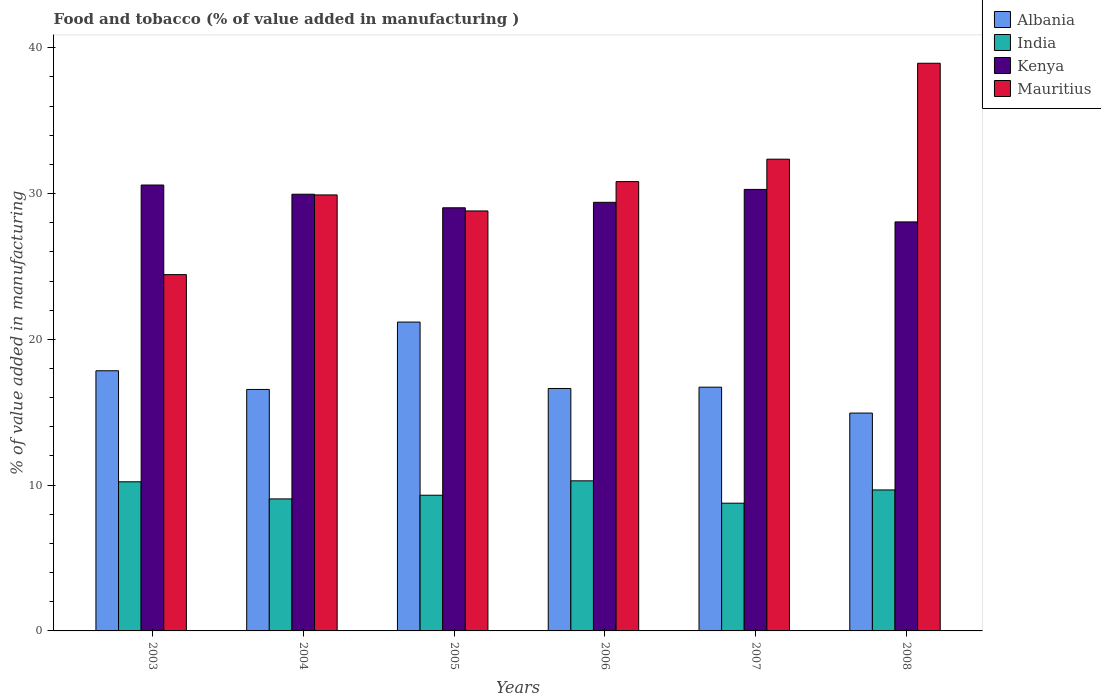How many groups of bars are there?
Your answer should be compact. 6. What is the label of the 3rd group of bars from the left?
Your answer should be very brief. 2005. What is the value added in manufacturing food and tobacco in India in 2007?
Offer a terse response. 8.76. Across all years, what is the maximum value added in manufacturing food and tobacco in Kenya?
Provide a succinct answer. 30.59. Across all years, what is the minimum value added in manufacturing food and tobacco in India?
Ensure brevity in your answer.  8.76. In which year was the value added in manufacturing food and tobacco in Albania minimum?
Keep it short and to the point. 2008. What is the total value added in manufacturing food and tobacco in Mauritius in the graph?
Make the answer very short. 185.29. What is the difference between the value added in manufacturing food and tobacco in India in 2004 and that in 2006?
Give a very brief answer. -1.24. What is the difference between the value added in manufacturing food and tobacco in India in 2008 and the value added in manufacturing food and tobacco in Albania in 2005?
Provide a succinct answer. -11.52. What is the average value added in manufacturing food and tobacco in Mauritius per year?
Make the answer very short. 30.88. In the year 2003, what is the difference between the value added in manufacturing food and tobacco in Mauritius and value added in manufacturing food and tobacco in Kenya?
Your answer should be very brief. -6.15. In how many years, is the value added in manufacturing food and tobacco in Albania greater than 12 %?
Make the answer very short. 6. What is the ratio of the value added in manufacturing food and tobacco in India in 2004 to that in 2008?
Give a very brief answer. 0.94. Is the difference between the value added in manufacturing food and tobacco in Mauritius in 2006 and 2008 greater than the difference between the value added in manufacturing food and tobacco in Kenya in 2006 and 2008?
Make the answer very short. No. What is the difference between the highest and the second highest value added in manufacturing food and tobacco in Kenya?
Your response must be concise. 0.3. What is the difference between the highest and the lowest value added in manufacturing food and tobacco in Albania?
Your answer should be compact. 6.24. In how many years, is the value added in manufacturing food and tobacco in Mauritius greater than the average value added in manufacturing food and tobacco in Mauritius taken over all years?
Your response must be concise. 2. Is the sum of the value added in manufacturing food and tobacco in India in 2003 and 2008 greater than the maximum value added in manufacturing food and tobacco in Mauritius across all years?
Provide a succinct answer. No. Is it the case that in every year, the sum of the value added in manufacturing food and tobacco in India and value added in manufacturing food and tobacco in Albania is greater than the sum of value added in manufacturing food and tobacco in Mauritius and value added in manufacturing food and tobacco in Kenya?
Give a very brief answer. No. What does the 4th bar from the left in 2003 represents?
Offer a terse response. Mauritius. What does the 2nd bar from the right in 2006 represents?
Your response must be concise. Kenya. What is the difference between two consecutive major ticks on the Y-axis?
Offer a terse response. 10. Does the graph contain grids?
Ensure brevity in your answer.  No. Where does the legend appear in the graph?
Ensure brevity in your answer.  Top right. How many legend labels are there?
Your answer should be very brief. 4. What is the title of the graph?
Your answer should be compact. Food and tobacco (% of value added in manufacturing ). Does "Burkina Faso" appear as one of the legend labels in the graph?
Make the answer very short. No. What is the label or title of the X-axis?
Your answer should be very brief. Years. What is the label or title of the Y-axis?
Give a very brief answer. % of value added in manufacturing. What is the % of value added in manufacturing in Albania in 2003?
Keep it short and to the point. 17.85. What is the % of value added in manufacturing in India in 2003?
Provide a succinct answer. 10.23. What is the % of value added in manufacturing in Kenya in 2003?
Ensure brevity in your answer.  30.59. What is the % of value added in manufacturing in Mauritius in 2003?
Keep it short and to the point. 24.44. What is the % of value added in manufacturing in Albania in 2004?
Provide a short and direct response. 16.57. What is the % of value added in manufacturing of India in 2004?
Provide a short and direct response. 9.06. What is the % of value added in manufacturing of Kenya in 2004?
Your answer should be compact. 29.96. What is the % of value added in manufacturing in Mauritius in 2004?
Your answer should be very brief. 29.91. What is the % of value added in manufacturing in Albania in 2005?
Offer a terse response. 21.19. What is the % of value added in manufacturing in India in 2005?
Provide a succinct answer. 9.31. What is the % of value added in manufacturing of Kenya in 2005?
Your answer should be very brief. 29.03. What is the % of value added in manufacturing of Mauritius in 2005?
Ensure brevity in your answer.  28.81. What is the % of value added in manufacturing of Albania in 2006?
Your answer should be compact. 16.63. What is the % of value added in manufacturing of India in 2006?
Keep it short and to the point. 10.3. What is the % of value added in manufacturing in Kenya in 2006?
Make the answer very short. 29.4. What is the % of value added in manufacturing in Mauritius in 2006?
Your response must be concise. 30.82. What is the % of value added in manufacturing of Albania in 2007?
Give a very brief answer. 16.72. What is the % of value added in manufacturing of India in 2007?
Give a very brief answer. 8.76. What is the % of value added in manufacturing in Kenya in 2007?
Your answer should be compact. 30.29. What is the % of value added in manufacturing in Mauritius in 2007?
Keep it short and to the point. 32.36. What is the % of value added in manufacturing in Albania in 2008?
Offer a very short reply. 14.95. What is the % of value added in manufacturing of India in 2008?
Offer a very short reply. 9.67. What is the % of value added in manufacturing of Kenya in 2008?
Your response must be concise. 28.06. What is the % of value added in manufacturing in Mauritius in 2008?
Offer a very short reply. 38.94. Across all years, what is the maximum % of value added in manufacturing in Albania?
Give a very brief answer. 21.19. Across all years, what is the maximum % of value added in manufacturing of India?
Give a very brief answer. 10.3. Across all years, what is the maximum % of value added in manufacturing in Kenya?
Provide a succinct answer. 30.59. Across all years, what is the maximum % of value added in manufacturing of Mauritius?
Your answer should be compact. 38.94. Across all years, what is the minimum % of value added in manufacturing of Albania?
Make the answer very short. 14.95. Across all years, what is the minimum % of value added in manufacturing of India?
Provide a succinct answer. 8.76. Across all years, what is the minimum % of value added in manufacturing in Kenya?
Offer a very short reply. 28.06. Across all years, what is the minimum % of value added in manufacturing in Mauritius?
Provide a succinct answer. 24.44. What is the total % of value added in manufacturing in Albania in the graph?
Ensure brevity in your answer.  103.9. What is the total % of value added in manufacturing in India in the graph?
Your answer should be compact. 57.33. What is the total % of value added in manufacturing of Kenya in the graph?
Your answer should be very brief. 177.33. What is the total % of value added in manufacturing of Mauritius in the graph?
Offer a terse response. 185.29. What is the difference between the % of value added in manufacturing of Albania in 2003 and that in 2004?
Offer a very short reply. 1.28. What is the difference between the % of value added in manufacturing of India in 2003 and that in 2004?
Your answer should be compact. 1.17. What is the difference between the % of value added in manufacturing of Kenya in 2003 and that in 2004?
Your answer should be very brief. 0.63. What is the difference between the % of value added in manufacturing in Mauritius in 2003 and that in 2004?
Your answer should be very brief. -5.47. What is the difference between the % of value added in manufacturing in Albania in 2003 and that in 2005?
Provide a short and direct response. -3.34. What is the difference between the % of value added in manufacturing in India in 2003 and that in 2005?
Give a very brief answer. 0.92. What is the difference between the % of value added in manufacturing in Kenya in 2003 and that in 2005?
Offer a terse response. 1.56. What is the difference between the % of value added in manufacturing of Mauritius in 2003 and that in 2005?
Make the answer very short. -4.37. What is the difference between the % of value added in manufacturing in Albania in 2003 and that in 2006?
Make the answer very short. 1.22. What is the difference between the % of value added in manufacturing in India in 2003 and that in 2006?
Your answer should be very brief. -0.07. What is the difference between the % of value added in manufacturing of Kenya in 2003 and that in 2006?
Provide a succinct answer. 1.19. What is the difference between the % of value added in manufacturing of Mauritius in 2003 and that in 2006?
Your answer should be compact. -6.38. What is the difference between the % of value added in manufacturing in Albania in 2003 and that in 2007?
Provide a short and direct response. 1.13. What is the difference between the % of value added in manufacturing in India in 2003 and that in 2007?
Your response must be concise. 1.47. What is the difference between the % of value added in manufacturing in Kenya in 2003 and that in 2007?
Provide a succinct answer. 0.3. What is the difference between the % of value added in manufacturing in Mauritius in 2003 and that in 2007?
Offer a very short reply. -7.92. What is the difference between the % of value added in manufacturing of Albania in 2003 and that in 2008?
Make the answer very short. 2.9. What is the difference between the % of value added in manufacturing of India in 2003 and that in 2008?
Keep it short and to the point. 0.56. What is the difference between the % of value added in manufacturing in Kenya in 2003 and that in 2008?
Offer a terse response. 2.53. What is the difference between the % of value added in manufacturing of Mauritius in 2003 and that in 2008?
Keep it short and to the point. -14.5. What is the difference between the % of value added in manufacturing of Albania in 2004 and that in 2005?
Your answer should be compact. -4.62. What is the difference between the % of value added in manufacturing of India in 2004 and that in 2005?
Provide a succinct answer. -0.25. What is the difference between the % of value added in manufacturing of Kenya in 2004 and that in 2005?
Offer a very short reply. 0.93. What is the difference between the % of value added in manufacturing of Mauritius in 2004 and that in 2005?
Your response must be concise. 1.1. What is the difference between the % of value added in manufacturing of Albania in 2004 and that in 2006?
Make the answer very short. -0.07. What is the difference between the % of value added in manufacturing in India in 2004 and that in 2006?
Offer a terse response. -1.24. What is the difference between the % of value added in manufacturing in Kenya in 2004 and that in 2006?
Offer a terse response. 0.56. What is the difference between the % of value added in manufacturing of Mauritius in 2004 and that in 2006?
Make the answer very short. -0.91. What is the difference between the % of value added in manufacturing in Albania in 2004 and that in 2007?
Ensure brevity in your answer.  -0.16. What is the difference between the % of value added in manufacturing in India in 2004 and that in 2007?
Your response must be concise. 0.29. What is the difference between the % of value added in manufacturing in Kenya in 2004 and that in 2007?
Provide a succinct answer. -0.33. What is the difference between the % of value added in manufacturing in Mauritius in 2004 and that in 2007?
Offer a terse response. -2.45. What is the difference between the % of value added in manufacturing of Albania in 2004 and that in 2008?
Ensure brevity in your answer.  1.62. What is the difference between the % of value added in manufacturing of India in 2004 and that in 2008?
Your response must be concise. -0.61. What is the difference between the % of value added in manufacturing of Kenya in 2004 and that in 2008?
Your response must be concise. 1.9. What is the difference between the % of value added in manufacturing of Mauritius in 2004 and that in 2008?
Ensure brevity in your answer.  -9.03. What is the difference between the % of value added in manufacturing in Albania in 2005 and that in 2006?
Your answer should be compact. 4.56. What is the difference between the % of value added in manufacturing in India in 2005 and that in 2006?
Your answer should be very brief. -0.99. What is the difference between the % of value added in manufacturing of Kenya in 2005 and that in 2006?
Ensure brevity in your answer.  -0.38. What is the difference between the % of value added in manufacturing of Mauritius in 2005 and that in 2006?
Your answer should be compact. -2.01. What is the difference between the % of value added in manufacturing in Albania in 2005 and that in 2007?
Offer a terse response. 4.47. What is the difference between the % of value added in manufacturing in India in 2005 and that in 2007?
Make the answer very short. 0.55. What is the difference between the % of value added in manufacturing of Kenya in 2005 and that in 2007?
Your response must be concise. -1.26. What is the difference between the % of value added in manufacturing in Mauritius in 2005 and that in 2007?
Provide a short and direct response. -3.55. What is the difference between the % of value added in manufacturing of Albania in 2005 and that in 2008?
Your answer should be very brief. 6.24. What is the difference between the % of value added in manufacturing in India in 2005 and that in 2008?
Make the answer very short. -0.36. What is the difference between the % of value added in manufacturing in Kenya in 2005 and that in 2008?
Provide a short and direct response. 0.97. What is the difference between the % of value added in manufacturing of Mauritius in 2005 and that in 2008?
Provide a succinct answer. -10.13. What is the difference between the % of value added in manufacturing of Albania in 2006 and that in 2007?
Offer a terse response. -0.09. What is the difference between the % of value added in manufacturing in India in 2006 and that in 2007?
Provide a short and direct response. 1.53. What is the difference between the % of value added in manufacturing of Kenya in 2006 and that in 2007?
Your answer should be compact. -0.89. What is the difference between the % of value added in manufacturing in Mauritius in 2006 and that in 2007?
Your answer should be very brief. -1.54. What is the difference between the % of value added in manufacturing in Albania in 2006 and that in 2008?
Provide a succinct answer. 1.69. What is the difference between the % of value added in manufacturing in India in 2006 and that in 2008?
Your response must be concise. 0.63. What is the difference between the % of value added in manufacturing in Kenya in 2006 and that in 2008?
Offer a very short reply. 1.34. What is the difference between the % of value added in manufacturing of Mauritius in 2006 and that in 2008?
Offer a terse response. -8.12. What is the difference between the % of value added in manufacturing in Albania in 2007 and that in 2008?
Your answer should be very brief. 1.78. What is the difference between the % of value added in manufacturing of India in 2007 and that in 2008?
Provide a short and direct response. -0.91. What is the difference between the % of value added in manufacturing of Kenya in 2007 and that in 2008?
Your response must be concise. 2.23. What is the difference between the % of value added in manufacturing in Mauritius in 2007 and that in 2008?
Offer a terse response. -6.58. What is the difference between the % of value added in manufacturing in Albania in 2003 and the % of value added in manufacturing in India in 2004?
Your answer should be very brief. 8.79. What is the difference between the % of value added in manufacturing of Albania in 2003 and the % of value added in manufacturing of Kenya in 2004?
Provide a short and direct response. -12.11. What is the difference between the % of value added in manufacturing of Albania in 2003 and the % of value added in manufacturing of Mauritius in 2004?
Ensure brevity in your answer.  -12.06. What is the difference between the % of value added in manufacturing in India in 2003 and the % of value added in manufacturing in Kenya in 2004?
Keep it short and to the point. -19.73. What is the difference between the % of value added in manufacturing of India in 2003 and the % of value added in manufacturing of Mauritius in 2004?
Ensure brevity in your answer.  -19.68. What is the difference between the % of value added in manufacturing of Kenya in 2003 and the % of value added in manufacturing of Mauritius in 2004?
Offer a terse response. 0.68. What is the difference between the % of value added in manufacturing in Albania in 2003 and the % of value added in manufacturing in India in 2005?
Your answer should be compact. 8.54. What is the difference between the % of value added in manufacturing of Albania in 2003 and the % of value added in manufacturing of Kenya in 2005?
Your answer should be very brief. -11.18. What is the difference between the % of value added in manufacturing of Albania in 2003 and the % of value added in manufacturing of Mauritius in 2005?
Provide a succinct answer. -10.96. What is the difference between the % of value added in manufacturing of India in 2003 and the % of value added in manufacturing of Kenya in 2005?
Your response must be concise. -18.8. What is the difference between the % of value added in manufacturing of India in 2003 and the % of value added in manufacturing of Mauritius in 2005?
Provide a succinct answer. -18.58. What is the difference between the % of value added in manufacturing in Kenya in 2003 and the % of value added in manufacturing in Mauritius in 2005?
Make the answer very short. 1.78. What is the difference between the % of value added in manufacturing of Albania in 2003 and the % of value added in manufacturing of India in 2006?
Your answer should be compact. 7.55. What is the difference between the % of value added in manufacturing in Albania in 2003 and the % of value added in manufacturing in Kenya in 2006?
Your answer should be very brief. -11.56. What is the difference between the % of value added in manufacturing of Albania in 2003 and the % of value added in manufacturing of Mauritius in 2006?
Provide a short and direct response. -12.98. What is the difference between the % of value added in manufacturing of India in 2003 and the % of value added in manufacturing of Kenya in 2006?
Provide a short and direct response. -19.17. What is the difference between the % of value added in manufacturing of India in 2003 and the % of value added in manufacturing of Mauritius in 2006?
Offer a very short reply. -20.59. What is the difference between the % of value added in manufacturing in Kenya in 2003 and the % of value added in manufacturing in Mauritius in 2006?
Offer a terse response. -0.23. What is the difference between the % of value added in manufacturing in Albania in 2003 and the % of value added in manufacturing in India in 2007?
Provide a succinct answer. 9.08. What is the difference between the % of value added in manufacturing in Albania in 2003 and the % of value added in manufacturing in Kenya in 2007?
Offer a terse response. -12.44. What is the difference between the % of value added in manufacturing of Albania in 2003 and the % of value added in manufacturing of Mauritius in 2007?
Your answer should be compact. -14.52. What is the difference between the % of value added in manufacturing in India in 2003 and the % of value added in manufacturing in Kenya in 2007?
Provide a short and direct response. -20.06. What is the difference between the % of value added in manufacturing of India in 2003 and the % of value added in manufacturing of Mauritius in 2007?
Provide a short and direct response. -22.13. What is the difference between the % of value added in manufacturing of Kenya in 2003 and the % of value added in manufacturing of Mauritius in 2007?
Give a very brief answer. -1.77. What is the difference between the % of value added in manufacturing in Albania in 2003 and the % of value added in manufacturing in India in 2008?
Your answer should be compact. 8.18. What is the difference between the % of value added in manufacturing of Albania in 2003 and the % of value added in manufacturing of Kenya in 2008?
Your answer should be very brief. -10.21. What is the difference between the % of value added in manufacturing of Albania in 2003 and the % of value added in manufacturing of Mauritius in 2008?
Your answer should be compact. -21.1. What is the difference between the % of value added in manufacturing in India in 2003 and the % of value added in manufacturing in Kenya in 2008?
Offer a terse response. -17.83. What is the difference between the % of value added in manufacturing of India in 2003 and the % of value added in manufacturing of Mauritius in 2008?
Ensure brevity in your answer.  -28.71. What is the difference between the % of value added in manufacturing of Kenya in 2003 and the % of value added in manufacturing of Mauritius in 2008?
Provide a succinct answer. -8.35. What is the difference between the % of value added in manufacturing of Albania in 2004 and the % of value added in manufacturing of India in 2005?
Give a very brief answer. 7.26. What is the difference between the % of value added in manufacturing of Albania in 2004 and the % of value added in manufacturing of Kenya in 2005?
Give a very brief answer. -12.46. What is the difference between the % of value added in manufacturing of Albania in 2004 and the % of value added in manufacturing of Mauritius in 2005?
Provide a succinct answer. -12.25. What is the difference between the % of value added in manufacturing of India in 2004 and the % of value added in manufacturing of Kenya in 2005?
Your answer should be compact. -19.97. What is the difference between the % of value added in manufacturing of India in 2004 and the % of value added in manufacturing of Mauritius in 2005?
Your answer should be compact. -19.75. What is the difference between the % of value added in manufacturing in Kenya in 2004 and the % of value added in manufacturing in Mauritius in 2005?
Your response must be concise. 1.15. What is the difference between the % of value added in manufacturing in Albania in 2004 and the % of value added in manufacturing in India in 2006?
Provide a succinct answer. 6.27. What is the difference between the % of value added in manufacturing in Albania in 2004 and the % of value added in manufacturing in Kenya in 2006?
Offer a terse response. -12.84. What is the difference between the % of value added in manufacturing of Albania in 2004 and the % of value added in manufacturing of Mauritius in 2006?
Your answer should be very brief. -14.26. What is the difference between the % of value added in manufacturing of India in 2004 and the % of value added in manufacturing of Kenya in 2006?
Make the answer very short. -20.35. What is the difference between the % of value added in manufacturing of India in 2004 and the % of value added in manufacturing of Mauritius in 2006?
Ensure brevity in your answer.  -21.77. What is the difference between the % of value added in manufacturing in Kenya in 2004 and the % of value added in manufacturing in Mauritius in 2006?
Keep it short and to the point. -0.87. What is the difference between the % of value added in manufacturing in Albania in 2004 and the % of value added in manufacturing in India in 2007?
Offer a terse response. 7.8. What is the difference between the % of value added in manufacturing of Albania in 2004 and the % of value added in manufacturing of Kenya in 2007?
Give a very brief answer. -13.72. What is the difference between the % of value added in manufacturing in Albania in 2004 and the % of value added in manufacturing in Mauritius in 2007?
Your response must be concise. -15.8. What is the difference between the % of value added in manufacturing of India in 2004 and the % of value added in manufacturing of Kenya in 2007?
Your answer should be very brief. -21.23. What is the difference between the % of value added in manufacturing of India in 2004 and the % of value added in manufacturing of Mauritius in 2007?
Offer a very short reply. -23.31. What is the difference between the % of value added in manufacturing of Kenya in 2004 and the % of value added in manufacturing of Mauritius in 2007?
Provide a succinct answer. -2.4. What is the difference between the % of value added in manufacturing in Albania in 2004 and the % of value added in manufacturing in India in 2008?
Offer a terse response. 6.89. What is the difference between the % of value added in manufacturing in Albania in 2004 and the % of value added in manufacturing in Kenya in 2008?
Offer a terse response. -11.49. What is the difference between the % of value added in manufacturing of Albania in 2004 and the % of value added in manufacturing of Mauritius in 2008?
Offer a terse response. -22.38. What is the difference between the % of value added in manufacturing in India in 2004 and the % of value added in manufacturing in Kenya in 2008?
Offer a very short reply. -19. What is the difference between the % of value added in manufacturing of India in 2004 and the % of value added in manufacturing of Mauritius in 2008?
Provide a short and direct response. -29.89. What is the difference between the % of value added in manufacturing of Kenya in 2004 and the % of value added in manufacturing of Mauritius in 2008?
Offer a terse response. -8.98. What is the difference between the % of value added in manufacturing of Albania in 2005 and the % of value added in manufacturing of India in 2006?
Keep it short and to the point. 10.89. What is the difference between the % of value added in manufacturing of Albania in 2005 and the % of value added in manufacturing of Kenya in 2006?
Provide a short and direct response. -8.22. What is the difference between the % of value added in manufacturing in Albania in 2005 and the % of value added in manufacturing in Mauritius in 2006?
Ensure brevity in your answer.  -9.64. What is the difference between the % of value added in manufacturing of India in 2005 and the % of value added in manufacturing of Kenya in 2006?
Make the answer very short. -20.09. What is the difference between the % of value added in manufacturing in India in 2005 and the % of value added in manufacturing in Mauritius in 2006?
Your answer should be compact. -21.52. What is the difference between the % of value added in manufacturing of Kenya in 2005 and the % of value added in manufacturing of Mauritius in 2006?
Ensure brevity in your answer.  -1.8. What is the difference between the % of value added in manufacturing of Albania in 2005 and the % of value added in manufacturing of India in 2007?
Give a very brief answer. 12.43. What is the difference between the % of value added in manufacturing of Albania in 2005 and the % of value added in manufacturing of Kenya in 2007?
Keep it short and to the point. -9.1. What is the difference between the % of value added in manufacturing in Albania in 2005 and the % of value added in manufacturing in Mauritius in 2007?
Ensure brevity in your answer.  -11.17. What is the difference between the % of value added in manufacturing in India in 2005 and the % of value added in manufacturing in Kenya in 2007?
Your answer should be compact. -20.98. What is the difference between the % of value added in manufacturing in India in 2005 and the % of value added in manufacturing in Mauritius in 2007?
Make the answer very short. -23.05. What is the difference between the % of value added in manufacturing in Kenya in 2005 and the % of value added in manufacturing in Mauritius in 2007?
Provide a short and direct response. -3.34. What is the difference between the % of value added in manufacturing in Albania in 2005 and the % of value added in manufacturing in India in 2008?
Provide a succinct answer. 11.52. What is the difference between the % of value added in manufacturing of Albania in 2005 and the % of value added in manufacturing of Kenya in 2008?
Give a very brief answer. -6.87. What is the difference between the % of value added in manufacturing of Albania in 2005 and the % of value added in manufacturing of Mauritius in 2008?
Your answer should be very brief. -17.75. What is the difference between the % of value added in manufacturing in India in 2005 and the % of value added in manufacturing in Kenya in 2008?
Give a very brief answer. -18.75. What is the difference between the % of value added in manufacturing of India in 2005 and the % of value added in manufacturing of Mauritius in 2008?
Your answer should be compact. -29.63. What is the difference between the % of value added in manufacturing in Kenya in 2005 and the % of value added in manufacturing in Mauritius in 2008?
Provide a succinct answer. -9.92. What is the difference between the % of value added in manufacturing of Albania in 2006 and the % of value added in manufacturing of India in 2007?
Keep it short and to the point. 7.87. What is the difference between the % of value added in manufacturing of Albania in 2006 and the % of value added in manufacturing of Kenya in 2007?
Keep it short and to the point. -13.66. What is the difference between the % of value added in manufacturing in Albania in 2006 and the % of value added in manufacturing in Mauritius in 2007?
Give a very brief answer. -15.73. What is the difference between the % of value added in manufacturing in India in 2006 and the % of value added in manufacturing in Kenya in 2007?
Your answer should be very brief. -19.99. What is the difference between the % of value added in manufacturing of India in 2006 and the % of value added in manufacturing of Mauritius in 2007?
Give a very brief answer. -22.07. What is the difference between the % of value added in manufacturing in Kenya in 2006 and the % of value added in manufacturing in Mauritius in 2007?
Offer a very short reply. -2.96. What is the difference between the % of value added in manufacturing of Albania in 2006 and the % of value added in manufacturing of India in 2008?
Provide a short and direct response. 6.96. What is the difference between the % of value added in manufacturing in Albania in 2006 and the % of value added in manufacturing in Kenya in 2008?
Provide a short and direct response. -11.43. What is the difference between the % of value added in manufacturing in Albania in 2006 and the % of value added in manufacturing in Mauritius in 2008?
Make the answer very short. -22.31. What is the difference between the % of value added in manufacturing in India in 2006 and the % of value added in manufacturing in Kenya in 2008?
Offer a very short reply. -17.76. What is the difference between the % of value added in manufacturing in India in 2006 and the % of value added in manufacturing in Mauritius in 2008?
Give a very brief answer. -28.65. What is the difference between the % of value added in manufacturing of Kenya in 2006 and the % of value added in manufacturing of Mauritius in 2008?
Offer a very short reply. -9.54. What is the difference between the % of value added in manufacturing of Albania in 2007 and the % of value added in manufacturing of India in 2008?
Your answer should be very brief. 7.05. What is the difference between the % of value added in manufacturing of Albania in 2007 and the % of value added in manufacturing of Kenya in 2008?
Ensure brevity in your answer.  -11.34. What is the difference between the % of value added in manufacturing in Albania in 2007 and the % of value added in manufacturing in Mauritius in 2008?
Provide a succinct answer. -22.22. What is the difference between the % of value added in manufacturing in India in 2007 and the % of value added in manufacturing in Kenya in 2008?
Ensure brevity in your answer.  -19.3. What is the difference between the % of value added in manufacturing of India in 2007 and the % of value added in manufacturing of Mauritius in 2008?
Make the answer very short. -30.18. What is the difference between the % of value added in manufacturing in Kenya in 2007 and the % of value added in manufacturing in Mauritius in 2008?
Provide a succinct answer. -8.65. What is the average % of value added in manufacturing in Albania per year?
Your answer should be very brief. 17.32. What is the average % of value added in manufacturing of India per year?
Offer a very short reply. 9.55. What is the average % of value added in manufacturing in Kenya per year?
Offer a terse response. 29.55. What is the average % of value added in manufacturing of Mauritius per year?
Your answer should be compact. 30.88. In the year 2003, what is the difference between the % of value added in manufacturing of Albania and % of value added in manufacturing of India?
Your answer should be compact. 7.62. In the year 2003, what is the difference between the % of value added in manufacturing of Albania and % of value added in manufacturing of Kenya?
Your answer should be compact. -12.74. In the year 2003, what is the difference between the % of value added in manufacturing of Albania and % of value added in manufacturing of Mauritius?
Ensure brevity in your answer.  -6.6. In the year 2003, what is the difference between the % of value added in manufacturing of India and % of value added in manufacturing of Kenya?
Make the answer very short. -20.36. In the year 2003, what is the difference between the % of value added in manufacturing in India and % of value added in manufacturing in Mauritius?
Make the answer very short. -14.21. In the year 2003, what is the difference between the % of value added in manufacturing of Kenya and % of value added in manufacturing of Mauritius?
Offer a terse response. 6.15. In the year 2004, what is the difference between the % of value added in manufacturing in Albania and % of value added in manufacturing in India?
Offer a terse response. 7.51. In the year 2004, what is the difference between the % of value added in manufacturing in Albania and % of value added in manufacturing in Kenya?
Your answer should be compact. -13.39. In the year 2004, what is the difference between the % of value added in manufacturing of Albania and % of value added in manufacturing of Mauritius?
Provide a short and direct response. -13.34. In the year 2004, what is the difference between the % of value added in manufacturing of India and % of value added in manufacturing of Kenya?
Offer a terse response. -20.9. In the year 2004, what is the difference between the % of value added in manufacturing in India and % of value added in manufacturing in Mauritius?
Keep it short and to the point. -20.85. In the year 2004, what is the difference between the % of value added in manufacturing in Kenya and % of value added in manufacturing in Mauritius?
Ensure brevity in your answer.  0.05. In the year 2005, what is the difference between the % of value added in manufacturing of Albania and % of value added in manufacturing of India?
Your response must be concise. 11.88. In the year 2005, what is the difference between the % of value added in manufacturing of Albania and % of value added in manufacturing of Kenya?
Provide a succinct answer. -7.84. In the year 2005, what is the difference between the % of value added in manufacturing in Albania and % of value added in manufacturing in Mauritius?
Offer a terse response. -7.62. In the year 2005, what is the difference between the % of value added in manufacturing in India and % of value added in manufacturing in Kenya?
Give a very brief answer. -19.72. In the year 2005, what is the difference between the % of value added in manufacturing of India and % of value added in manufacturing of Mauritius?
Make the answer very short. -19.5. In the year 2005, what is the difference between the % of value added in manufacturing of Kenya and % of value added in manufacturing of Mauritius?
Provide a succinct answer. 0.22. In the year 2006, what is the difference between the % of value added in manufacturing in Albania and % of value added in manufacturing in India?
Make the answer very short. 6.34. In the year 2006, what is the difference between the % of value added in manufacturing in Albania and % of value added in manufacturing in Kenya?
Make the answer very short. -12.77. In the year 2006, what is the difference between the % of value added in manufacturing in Albania and % of value added in manufacturing in Mauritius?
Provide a short and direct response. -14.19. In the year 2006, what is the difference between the % of value added in manufacturing of India and % of value added in manufacturing of Kenya?
Keep it short and to the point. -19.11. In the year 2006, what is the difference between the % of value added in manufacturing of India and % of value added in manufacturing of Mauritius?
Provide a short and direct response. -20.53. In the year 2006, what is the difference between the % of value added in manufacturing in Kenya and % of value added in manufacturing in Mauritius?
Offer a terse response. -1.42. In the year 2007, what is the difference between the % of value added in manufacturing in Albania and % of value added in manufacturing in India?
Provide a short and direct response. 7.96. In the year 2007, what is the difference between the % of value added in manufacturing in Albania and % of value added in manufacturing in Kenya?
Your response must be concise. -13.57. In the year 2007, what is the difference between the % of value added in manufacturing in Albania and % of value added in manufacturing in Mauritius?
Your answer should be very brief. -15.64. In the year 2007, what is the difference between the % of value added in manufacturing in India and % of value added in manufacturing in Kenya?
Your answer should be very brief. -21.53. In the year 2007, what is the difference between the % of value added in manufacturing of India and % of value added in manufacturing of Mauritius?
Provide a short and direct response. -23.6. In the year 2007, what is the difference between the % of value added in manufacturing in Kenya and % of value added in manufacturing in Mauritius?
Keep it short and to the point. -2.07. In the year 2008, what is the difference between the % of value added in manufacturing of Albania and % of value added in manufacturing of India?
Keep it short and to the point. 5.27. In the year 2008, what is the difference between the % of value added in manufacturing in Albania and % of value added in manufacturing in Kenya?
Ensure brevity in your answer.  -13.11. In the year 2008, what is the difference between the % of value added in manufacturing in Albania and % of value added in manufacturing in Mauritius?
Keep it short and to the point. -24. In the year 2008, what is the difference between the % of value added in manufacturing of India and % of value added in manufacturing of Kenya?
Keep it short and to the point. -18.39. In the year 2008, what is the difference between the % of value added in manufacturing in India and % of value added in manufacturing in Mauritius?
Make the answer very short. -29.27. In the year 2008, what is the difference between the % of value added in manufacturing in Kenya and % of value added in manufacturing in Mauritius?
Your answer should be very brief. -10.88. What is the ratio of the % of value added in manufacturing in Albania in 2003 to that in 2004?
Provide a succinct answer. 1.08. What is the ratio of the % of value added in manufacturing in India in 2003 to that in 2004?
Make the answer very short. 1.13. What is the ratio of the % of value added in manufacturing in Kenya in 2003 to that in 2004?
Offer a terse response. 1.02. What is the ratio of the % of value added in manufacturing of Mauritius in 2003 to that in 2004?
Offer a very short reply. 0.82. What is the ratio of the % of value added in manufacturing of Albania in 2003 to that in 2005?
Ensure brevity in your answer.  0.84. What is the ratio of the % of value added in manufacturing in India in 2003 to that in 2005?
Ensure brevity in your answer.  1.1. What is the ratio of the % of value added in manufacturing of Kenya in 2003 to that in 2005?
Your response must be concise. 1.05. What is the ratio of the % of value added in manufacturing of Mauritius in 2003 to that in 2005?
Ensure brevity in your answer.  0.85. What is the ratio of the % of value added in manufacturing in Albania in 2003 to that in 2006?
Give a very brief answer. 1.07. What is the ratio of the % of value added in manufacturing in Kenya in 2003 to that in 2006?
Offer a very short reply. 1.04. What is the ratio of the % of value added in manufacturing in Mauritius in 2003 to that in 2006?
Ensure brevity in your answer.  0.79. What is the ratio of the % of value added in manufacturing of Albania in 2003 to that in 2007?
Your response must be concise. 1.07. What is the ratio of the % of value added in manufacturing in India in 2003 to that in 2007?
Make the answer very short. 1.17. What is the ratio of the % of value added in manufacturing of Kenya in 2003 to that in 2007?
Give a very brief answer. 1.01. What is the ratio of the % of value added in manufacturing in Mauritius in 2003 to that in 2007?
Your answer should be compact. 0.76. What is the ratio of the % of value added in manufacturing in Albania in 2003 to that in 2008?
Ensure brevity in your answer.  1.19. What is the ratio of the % of value added in manufacturing in India in 2003 to that in 2008?
Offer a very short reply. 1.06. What is the ratio of the % of value added in manufacturing of Kenya in 2003 to that in 2008?
Make the answer very short. 1.09. What is the ratio of the % of value added in manufacturing in Mauritius in 2003 to that in 2008?
Ensure brevity in your answer.  0.63. What is the ratio of the % of value added in manufacturing of Albania in 2004 to that in 2005?
Give a very brief answer. 0.78. What is the ratio of the % of value added in manufacturing of India in 2004 to that in 2005?
Provide a succinct answer. 0.97. What is the ratio of the % of value added in manufacturing in Kenya in 2004 to that in 2005?
Keep it short and to the point. 1.03. What is the ratio of the % of value added in manufacturing in Mauritius in 2004 to that in 2005?
Keep it short and to the point. 1.04. What is the ratio of the % of value added in manufacturing in India in 2004 to that in 2006?
Give a very brief answer. 0.88. What is the ratio of the % of value added in manufacturing of Kenya in 2004 to that in 2006?
Your answer should be compact. 1.02. What is the ratio of the % of value added in manufacturing in Mauritius in 2004 to that in 2006?
Your answer should be compact. 0.97. What is the ratio of the % of value added in manufacturing in India in 2004 to that in 2007?
Ensure brevity in your answer.  1.03. What is the ratio of the % of value added in manufacturing in Mauritius in 2004 to that in 2007?
Your answer should be compact. 0.92. What is the ratio of the % of value added in manufacturing in Albania in 2004 to that in 2008?
Offer a terse response. 1.11. What is the ratio of the % of value added in manufacturing of India in 2004 to that in 2008?
Offer a very short reply. 0.94. What is the ratio of the % of value added in manufacturing in Kenya in 2004 to that in 2008?
Your answer should be very brief. 1.07. What is the ratio of the % of value added in manufacturing in Mauritius in 2004 to that in 2008?
Make the answer very short. 0.77. What is the ratio of the % of value added in manufacturing in Albania in 2005 to that in 2006?
Your answer should be very brief. 1.27. What is the ratio of the % of value added in manufacturing of India in 2005 to that in 2006?
Give a very brief answer. 0.9. What is the ratio of the % of value added in manufacturing of Kenya in 2005 to that in 2006?
Your answer should be compact. 0.99. What is the ratio of the % of value added in manufacturing of Mauritius in 2005 to that in 2006?
Offer a terse response. 0.93. What is the ratio of the % of value added in manufacturing in Albania in 2005 to that in 2007?
Keep it short and to the point. 1.27. What is the ratio of the % of value added in manufacturing in India in 2005 to that in 2007?
Your answer should be very brief. 1.06. What is the ratio of the % of value added in manufacturing of Kenya in 2005 to that in 2007?
Provide a short and direct response. 0.96. What is the ratio of the % of value added in manufacturing in Mauritius in 2005 to that in 2007?
Your answer should be very brief. 0.89. What is the ratio of the % of value added in manufacturing of Albania in 2005 to that in 2008?
Ensure brevity in your answer.  1.42. What is the ratio of the % of value added in manufacturing in India in 2005 to that in 2008?
Make the answer very short. 0.96. What is the ratio of the % of value added in manufacturing of Kenya in 2005 to that in 2008?
Your answer should be very brief. 1.03. What is the ratio of the % of value added in manufacturing of Mauritius in 2005 to that in 2008?
Your answer should be very brief. 0.74. What is the ratio of the % of value added in manufacturing in India in 2006 to that in 2007?
Your answer should be compact. 1.18. What is the ratio of the % of value added in manufacturing of Kenya in 2006 to that in 2007?
Keep it short and to the point. 0.97. What is the ratio of the % of value added in manufacturing of Mauritius in 2006 to that in 2007?
Offer a very short reply. 0.95. What is the ratio of the % of value added in manufacturing in Albania in 2006 to that in 2008?
Give a very brief answer. 1.11. What is the ratio of the % of value added in manufacturing in India in 2006 to that in 2008?
Give a very brief answer. 1.06. What is the ratio of the % of value added in manufacturing of Kenya in 2006 to that in 2008?
Your answer should be very brief. 1.05. What is the ratio of the % of value added in manufacturing of Mauritius in 2006 to that in 2008?
Your answer should be very brief. 0.79. What is the ratio of the % of value added in manufacturing in Albania in 2007 to that in 2008?
Offer a very short reply. 1.12. What is the ratio of the % of value added in manufacturing in India in 2007 to that in 2008?
Offer a terse response. 0.91. What is the ratio of the % of value added in manufacturing in Kenya in 2007 to that in 2008?
Ensure brevity in your answer.  1.08. What is the ratio of the % of value added in manufacturing of Mauritius in 2007 to that in 2008?
Keep it short and to the point. 0.83. What is the difference between the highest and the second highest % of value added in manufacturing in Albania?
Your response must be concise. 3.34. What is the difference between the highest and the second highest % of value added in manufacturing in India?
Your response must be concise. 0.07. What is the difference between the highest and the second highest % of value added in manufacturing of Kenya?
Offer a terse response. 0.3. What is the difference between the highest and the second highest % of value added in manufacturing of Mauritius?
Your answer should be very brief. 6.58. What is the difference between the highest and the lowest % of value added in manufacturing in Albania?
Make the answer very short. 6.24. What is the difference between the highest and the lowest % of value added in manufacturing in India?
Give a very brief answer. 1.53. What is the difference between the highest and the lowest % of value added in manufacturing in Kenya?
Offer a terse response. 2.53. What is the difference between the highest and the lowest % of value added in manufacturing in Mauritius?
Provide a short and direct response. 14.5. 